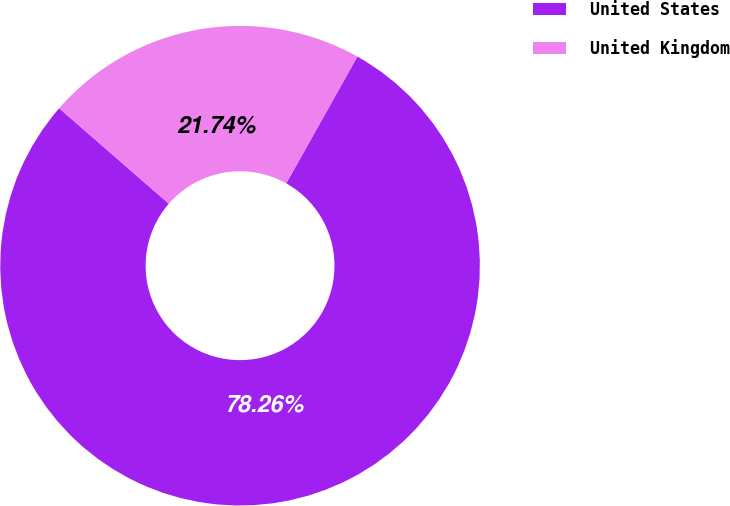Convert chart. <chart><loc_0><loc_0><loc_500><loc_500><pie_chart><fcel>United States<fcel>United Kingdom<nl><fcel>78.26%<fcel>21.74%<nl></chart> 